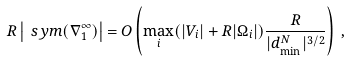Convert formula to latex. <formula><loc_0><loc_0><loc_500><loc_500>R \left | \ s y m ( \nabla _ { 1 } ^ { \infty } ) \right | = O \left ( \underset { i } { \max } ( | V _ { i } | + R | \Omega _ { i } | ) \frac { R } { | d _ { \min } ^ { N } | ^ { 3 / 2 } } \right ) \, ,</formula> 